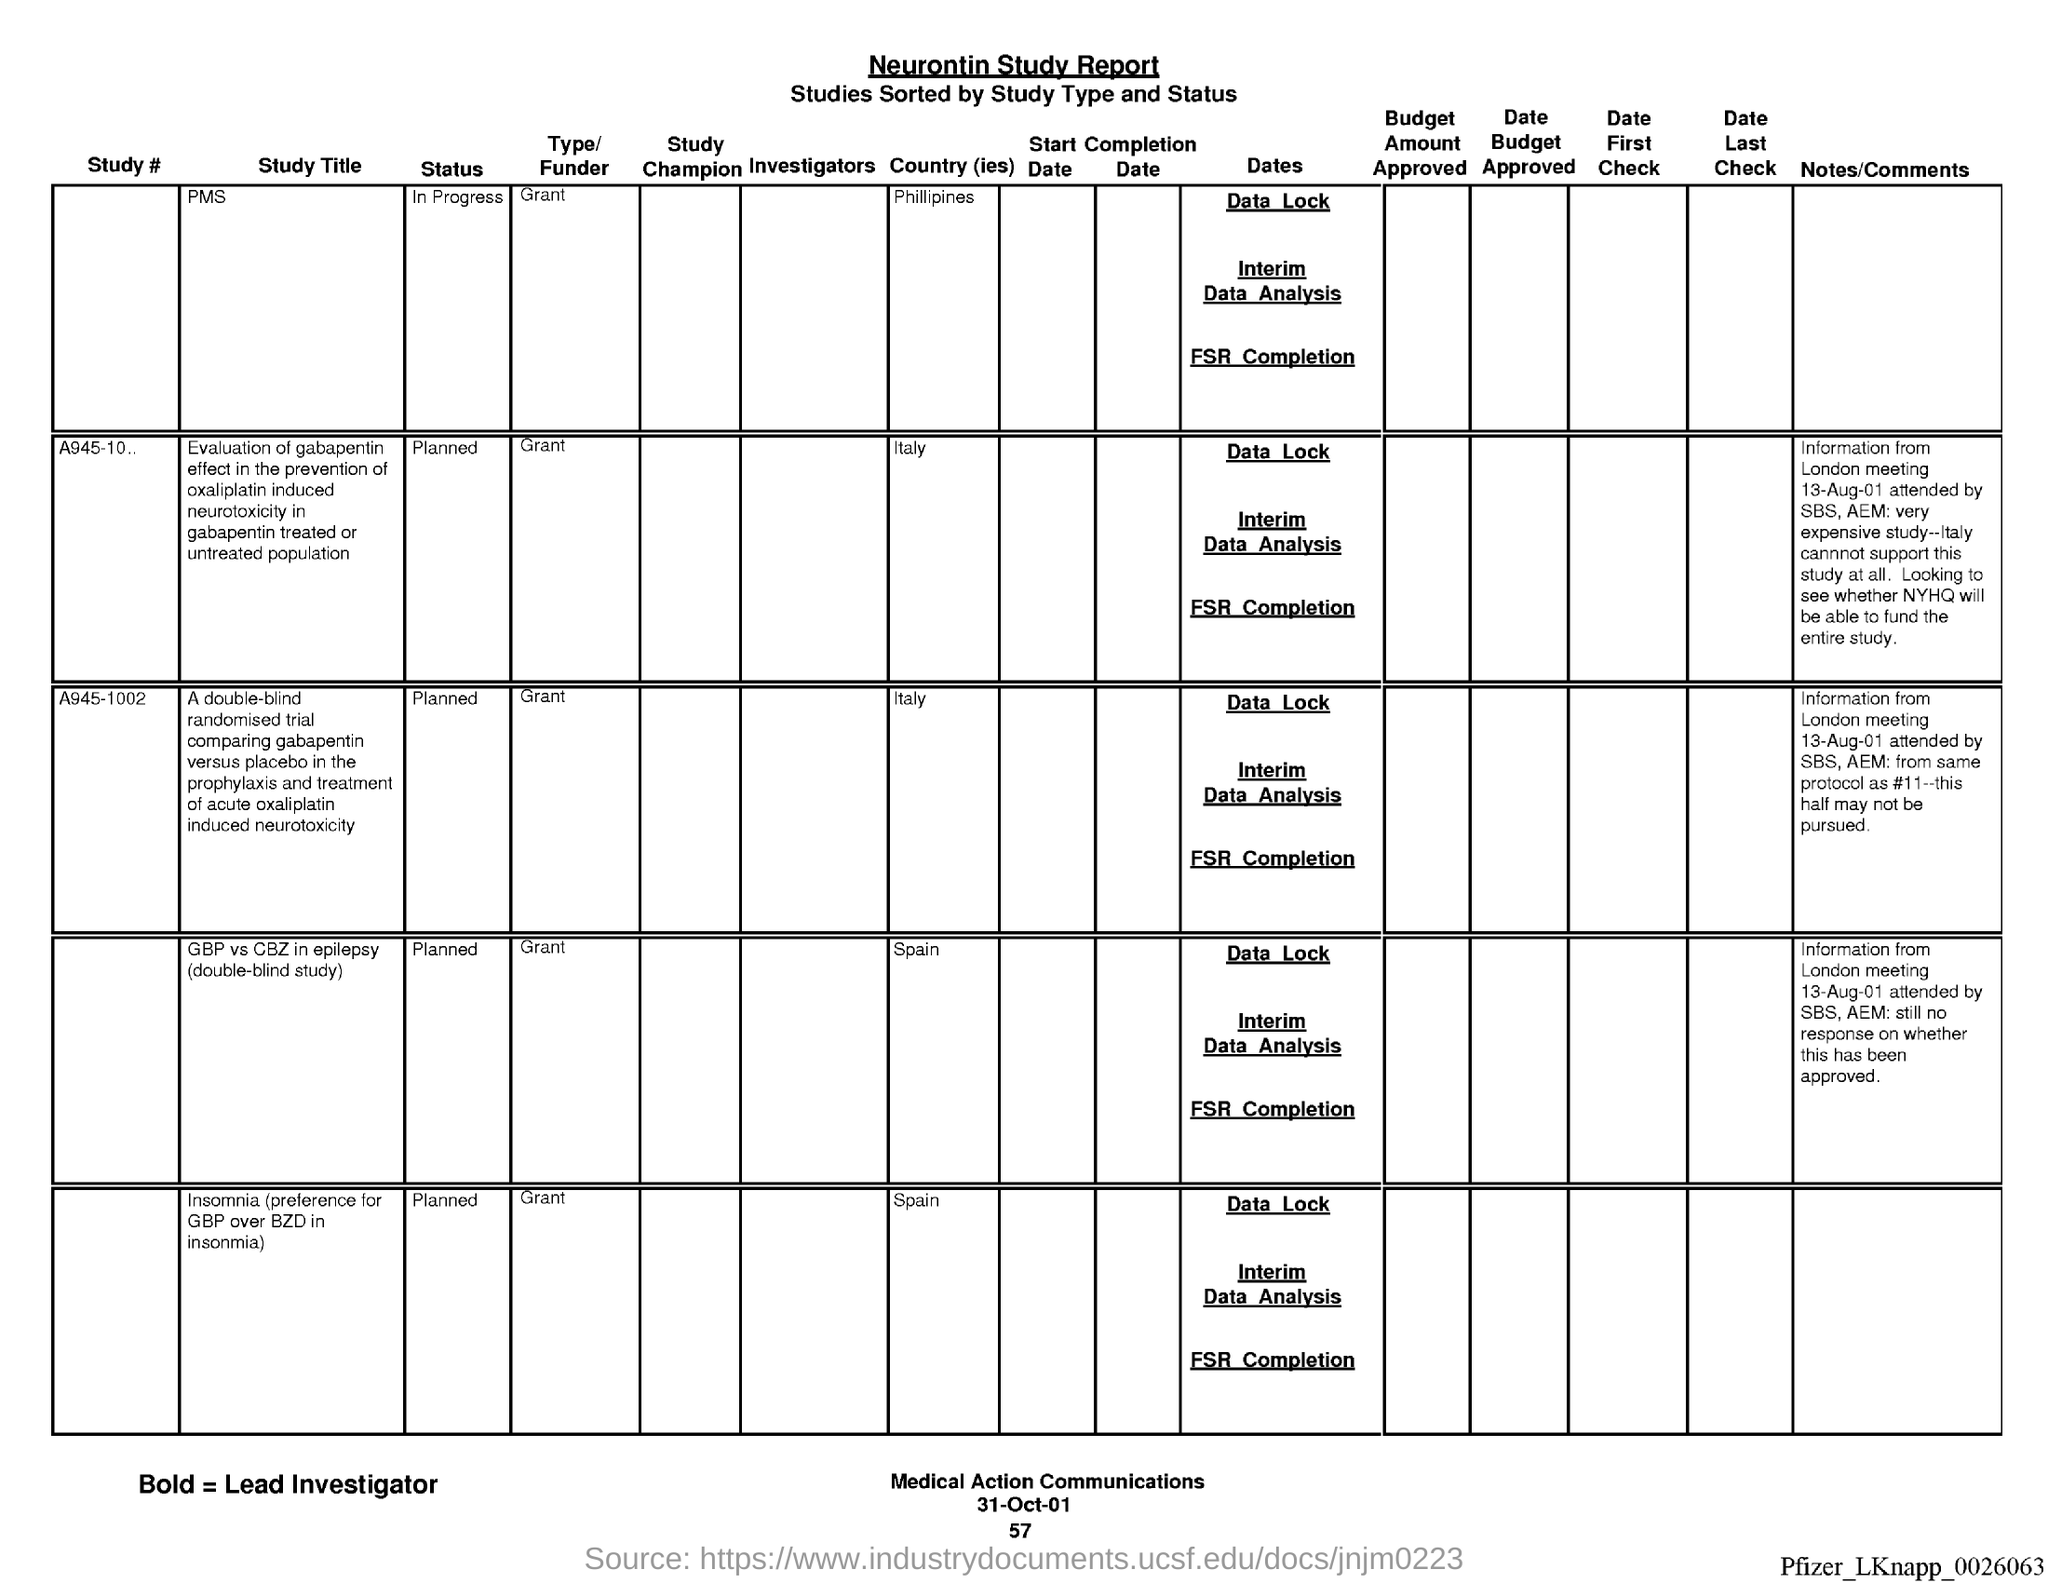Indicate a few pertinent items in this graphic. The page number below the date on March 3, 2023, is 57. The name of the report is the Neurontin Study report. On the bottom of the page, the date can be seen as '31-oct-01'. 